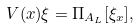Convert formula to latex. <formula><loc_0><loc_0><loc_500><loc_500>V ( x ) \xi = \Pi _ { A _ { L } } [ \xi _ { x } ] ,</formula> 